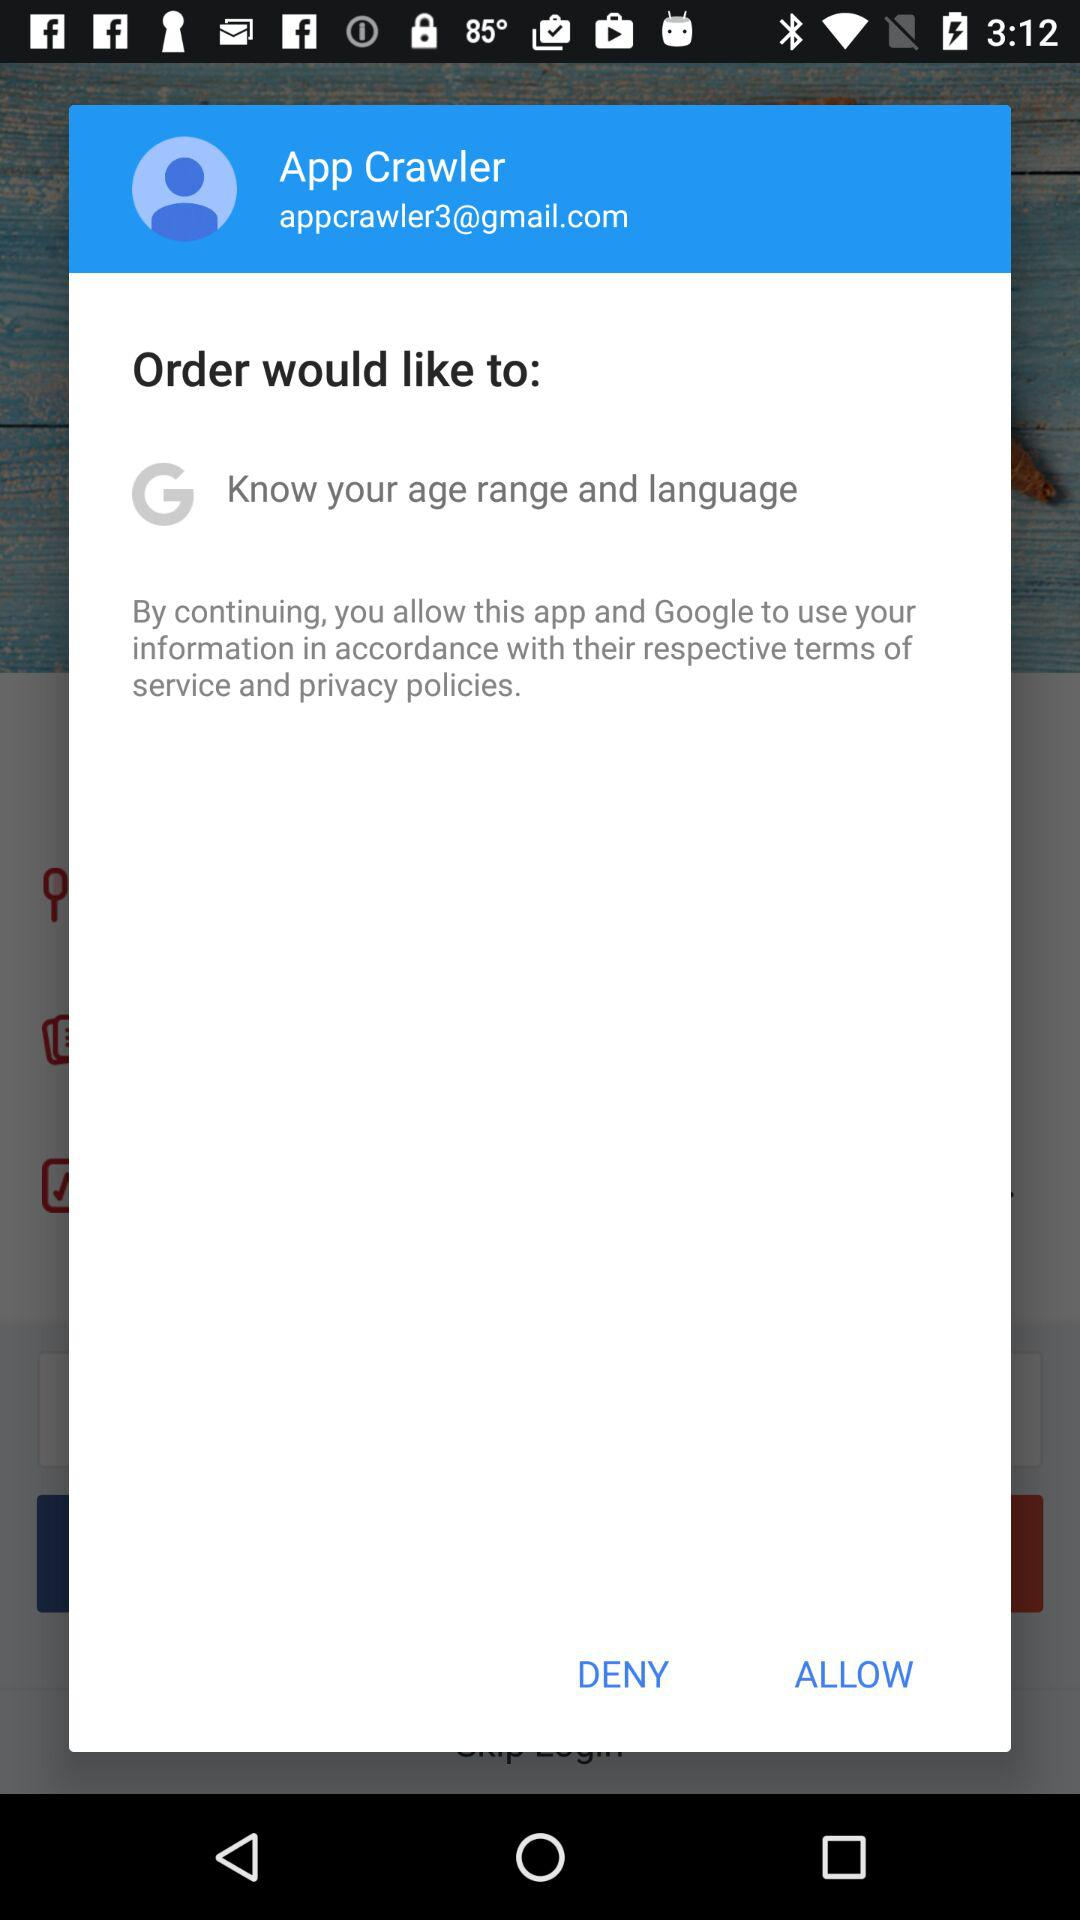What is the username? The username is "App Crawler". 